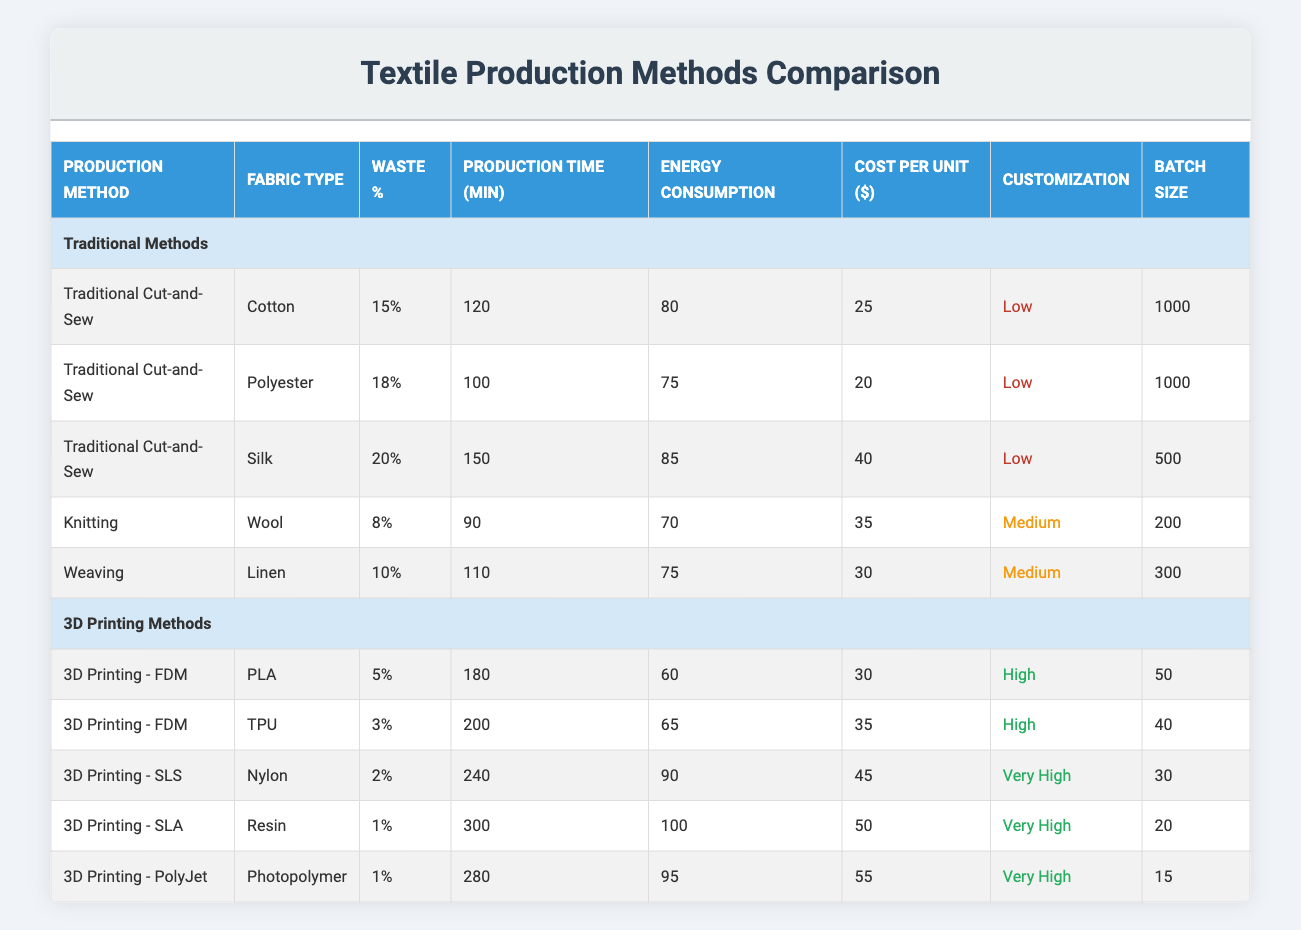What is the waste percentage for 3D printing using SLA? The table shows that the waste percentage for "3D Printing - SLA" is 1%.
Answer: 1% Which traditional production method has the highest cost per unit? Looking at the "Cost Per Unit" column for traditional methods, "Traditional Cut-and-Sew" for Silk has the highest cost at $40.
Answer: $40 What is the average waste percentage for all 3D printing methods? The waste percentages for 3D printing methods are: 5%, 3%, 2%, 1%, and 1%. Summing these yields 12%, and there are 5 data points. Thus, the average is 12%/5 = 2.4%.
Answer: 2.4% Is the energy consumption for "Knitting" higher than that for "Weaving"? "Knitting" has an energy consumption of 70 while "Weaving" has 75. Since 70 is less than 75, the statement is false.
Answer: No What is the total production time for all traditional methods? The production times for traditional methods are: 120, 100, 150, 90, and 110 minutes. Adding these gives 570 minutes.
Answer: 570 minutes Which 3D printing method has the lowest waste percentage? The table shows that "3D Printing - SLS" has a waste percentage of 2%, which is the lowest among all methods listed.
Answer: 2% Are the customization levels for all traditional methods low? All traditional methods listed have a customization level marked as low, so the answer is yes.
Answer: Yes What is the difference in batch size between the highest and lowest batch sizes in 3D printing? The highest batch size in the 3D printing section is 50 (from FDM) and the lowest is 15 (from PolyJet). The difference is 50 - 15 = 35.
Answer: 35 